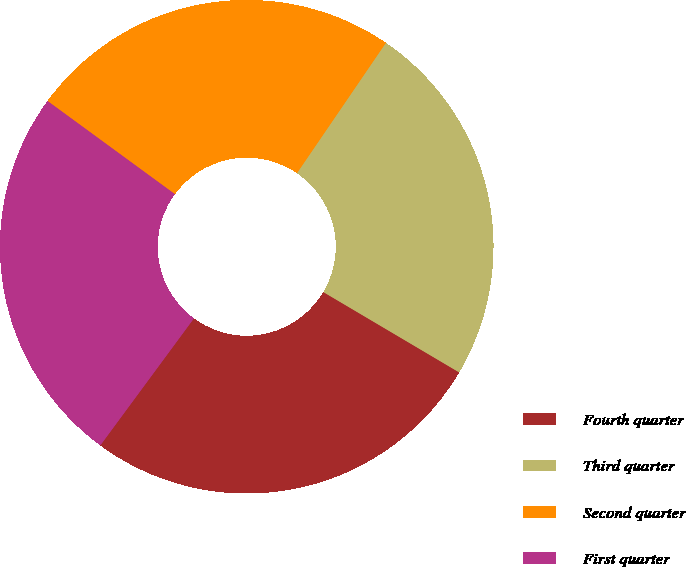Convert chart to OTSL. <chart><loc_0><loc_0><loc_500><loc_500><pie_chart><fcel>Fourth quarter<fcel>Third quarter<fcel>Second quarter<fcel>First quarter<nl><fcel>26.61%<fcel>23.97%<fcel>24.48%<fcel>24.94%<nl></chart> 